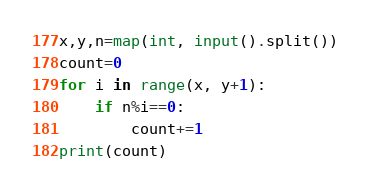Convert code to text. <code><loc_0><loc_0><loc_500><loc_500><_Python_>x,y,n=map(int, input().split())
count=0
for i in range(x, y+1):
    if n%i==0:
        count+=1
print(count)
</code> 